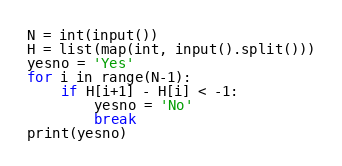<code> <loc_0><loc_0><loc_500><loc_500><_Python_>N = int(input())
H = list(map(int, input().split()))
yesno = 'Yes'
for i in range(N-1):
    if H[i+1] - H[i] < -1:
        yesno = 'No'
        break
print(yesno)</code> 